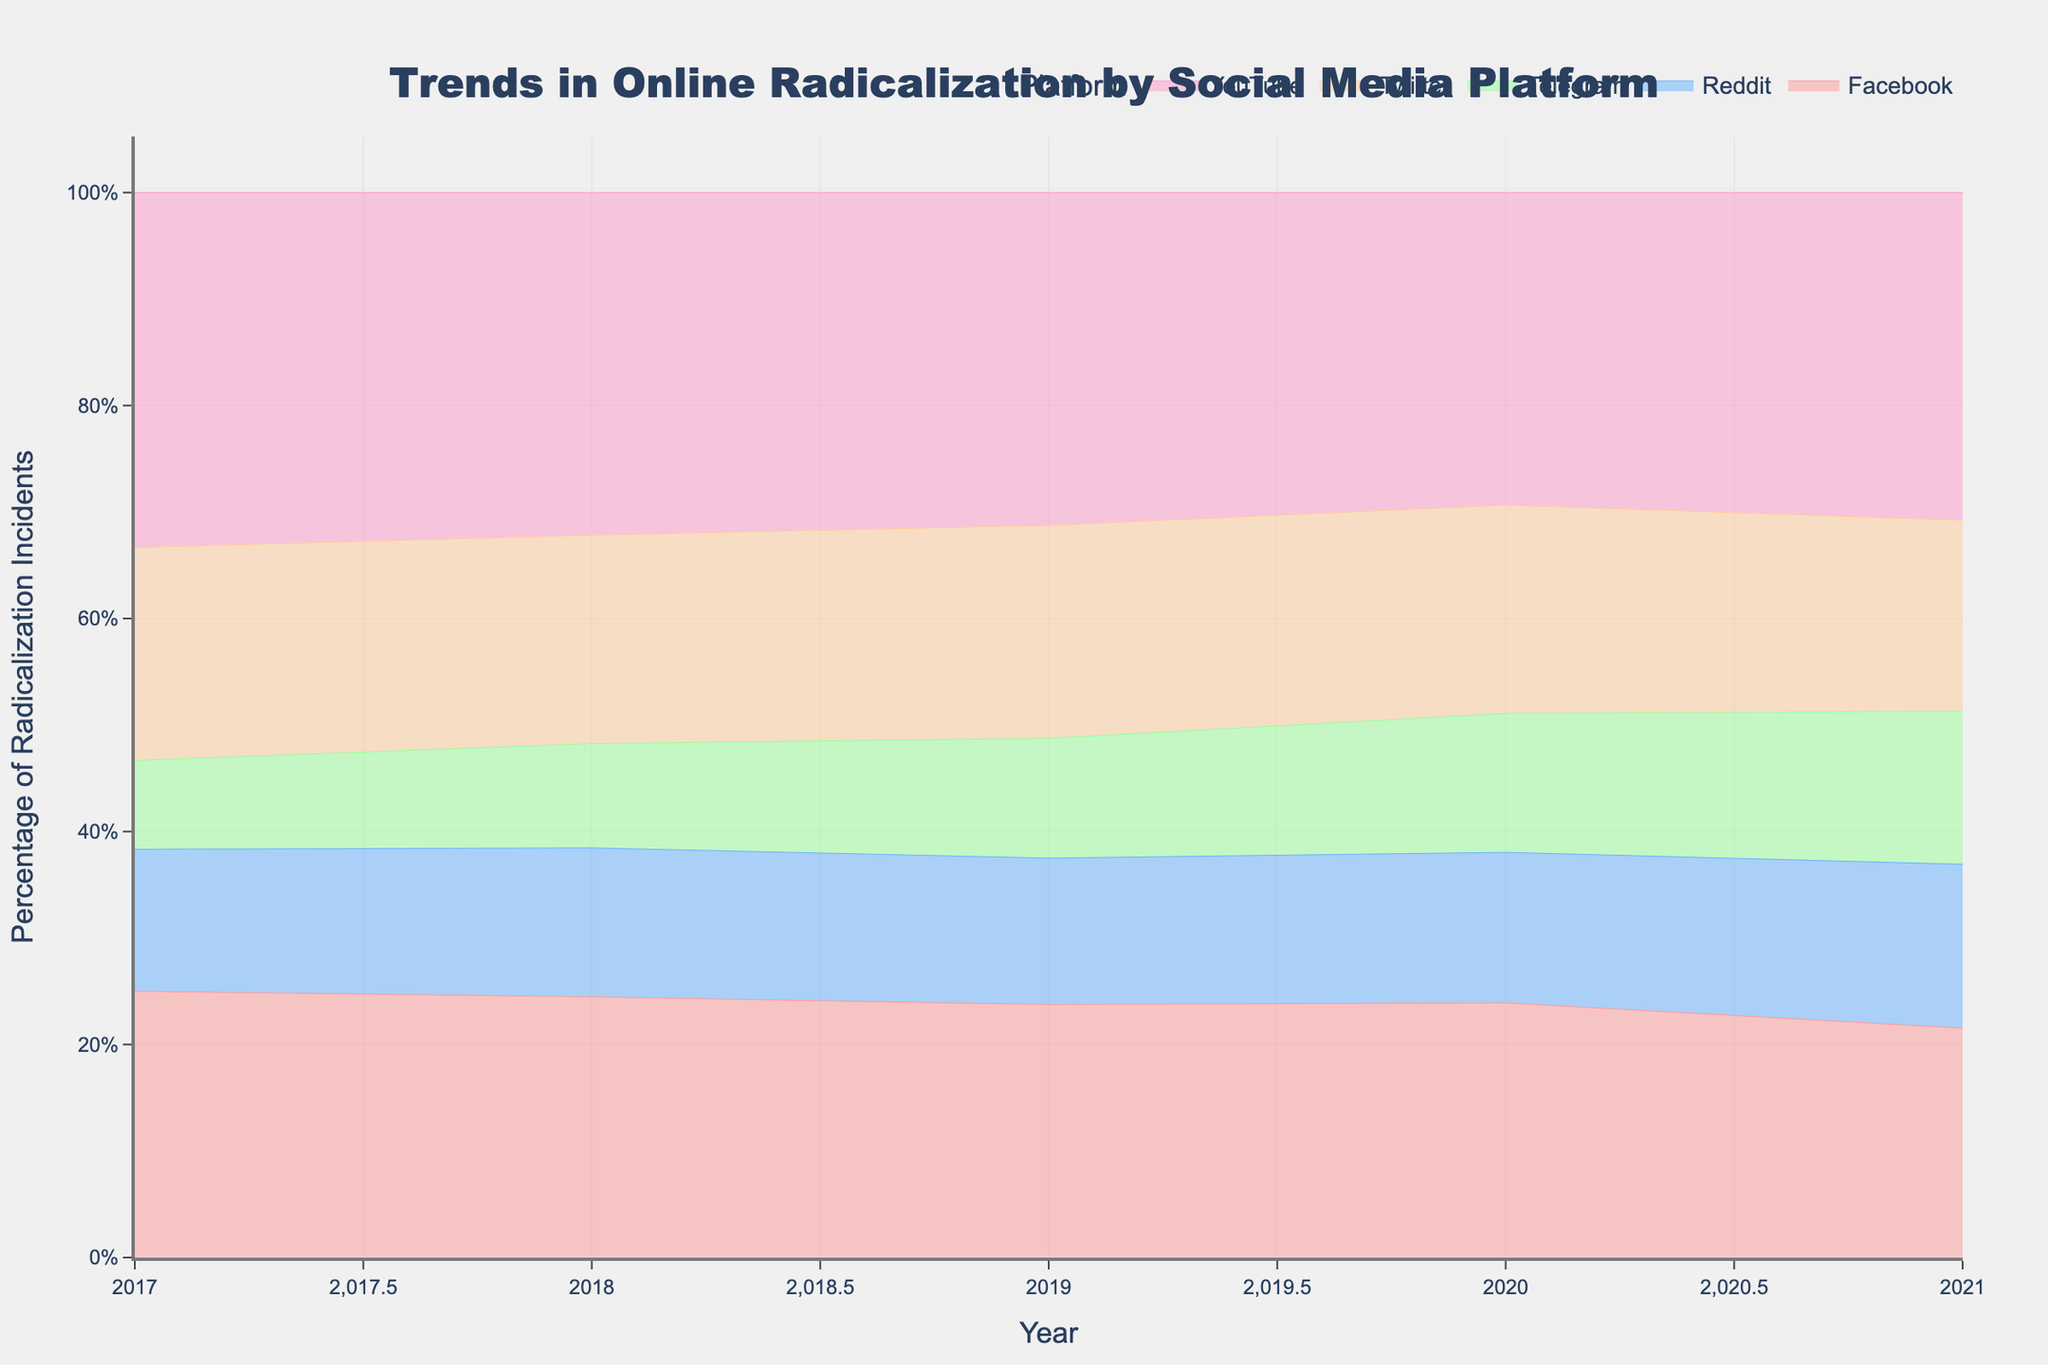What is the title of the chart? The title is usually placed at the top of the chart. Here, it clearly mentions "Trends in Online Radicalization by Social Media Platform".
Answer: Trends in Online Radicalization by Social Media Platform What is the range of years covered in the chart? The x-axis of the chart usually denotes the time range, with the years listed underneath it. Here, the years range from 2017 to 2021.
Answer: 2017 to 2021 Which social media platform had the highest number of radicalization incidents each year? By looking at the height of the streams at each year marker and identifying the one with the highest value, we see that YouTube has the highest number in all years from 2017 to 2021.
Answer: YouTube How does the number of radicalization incidents on Twitter in 2017 compare to 2021? Observe the height of the stream corresponding to Twitter for 2017 and 2021. In 2017, there are 120 incidents; in 2021, there are 175. Therefore, the number has increased.
Answer: Increased Which platform showed the most significant increase in radicalization incidents from 2017 to 2021? Calculate the difference in the height of the stream from 2017 to 2021 for each platform. YouTube shows the most significant increase from 200 incidents in 2017 to 300 in 2021, an increase of 100 incidents.
Answer: YouTube What percentage of radicalization incidents were attributed to Reddit in 2020? Using the stack in 2020, find the height corresponding to Reddit, which is 130 incidents. Sum all incidents across platforms that year to find the total. Reddit's incidents (130) divided by the total number (920) gives approximately 14.13%.
Answer: Approximately 14.13% Compare the trends of Facebook and Telegram from 2017 to 2021. Compare the height of the streams for both platforms across the years. Facebook increased from 150 to 210, showing an overall steady rise with slight fluctuation, while Telegram increased steadily from 50 to 140, showing more consistent growth.
Answer: Facebook had a steady rise with slight fluctuations, while Telegram had consistent growth In which year did the total number of radicalization incidents reach its peak? Add up the stream heights for all platforms for each year. The peak is where the sum is highest. In this case, 2021 shows the highest total with a summation of 975 incidents.
Answer: 2021 What is the overall trend for the total number of radicalization incidents from 2017 to 2021? Look at the overall height of all streams combined for each year. The total number increases overall from 600 in 2017 to 975 in 2021, indicating an upward trend.
Answer: Upward trend 